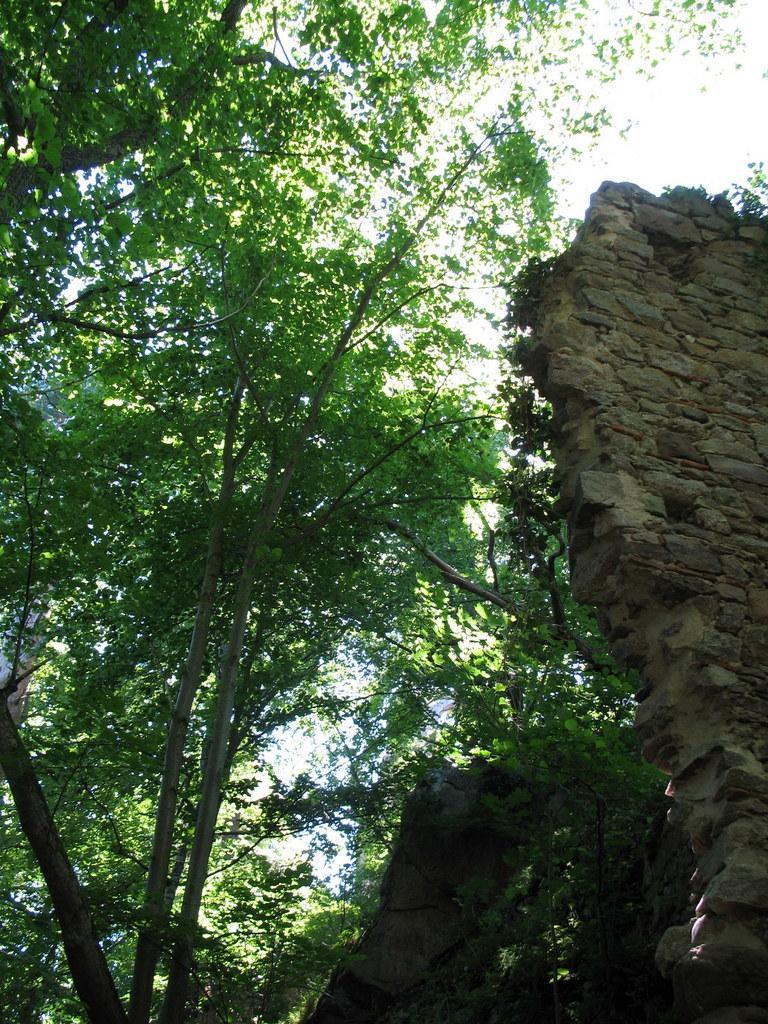Describe this image in one or two sentences. In this image I see trees and I see a wall over here which is made of stones and I see the sky. 